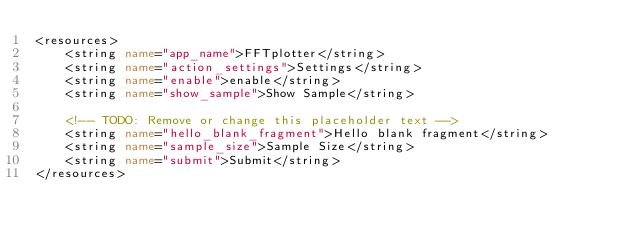Convert code to text. <code><loc_0><loc_0><loc_500><loc_500><_XML_><resources>
    <string name="app_name">FFTplotter</string>
    <string name="action_settings">Settings</string>
    <string name="enable">enable</string>
    <string name="show_sample">Show Sample</string>

    <!-- TODO: Remove or change this placeholder text -->
    <string name="hello_blank_fragment">Hello blank fragment</string>
    <string name="sample_size">Sample Size</string>
    <string name="submit">Submit</string>
</resources>
</code> 